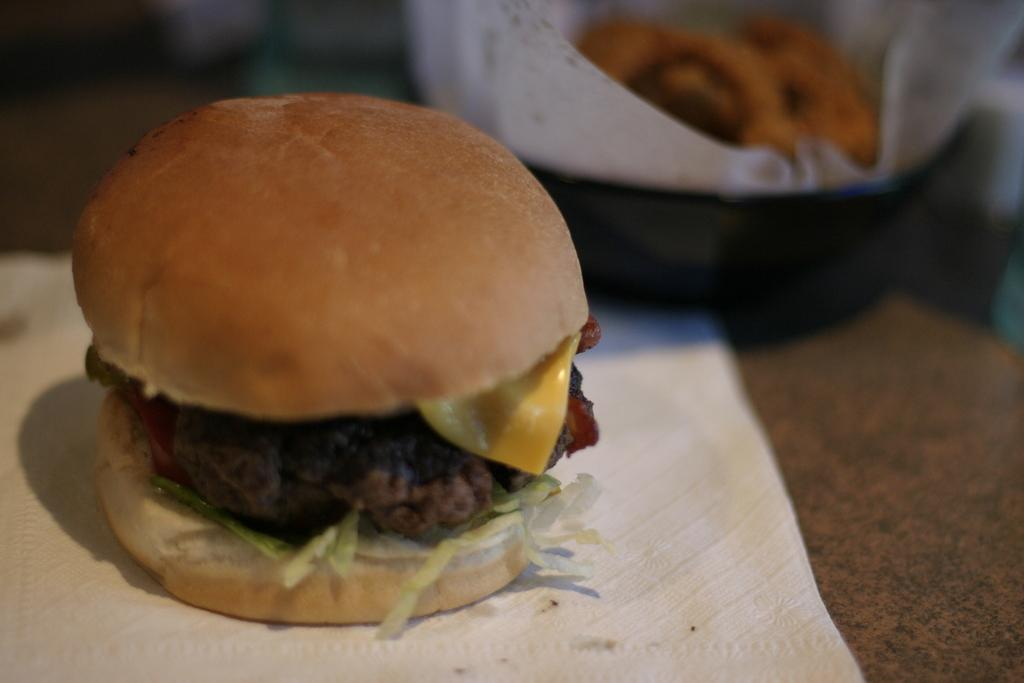What is the main piece of furniture in the image? There is a table in the image. What type of food can be seen on the table? There is a burger on the table. What item is present for wiping or cleaning purposes? There is a napkin on the table. What else is on the table besides the burger and napkin? There is a tray containing food on the table. What time is displayed on the clock in the image? There is no clock present in the image. 